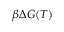<formula> <loc_0><loc_0><loc_500><loc_500>\beta \Delta G ( T )</formula> 